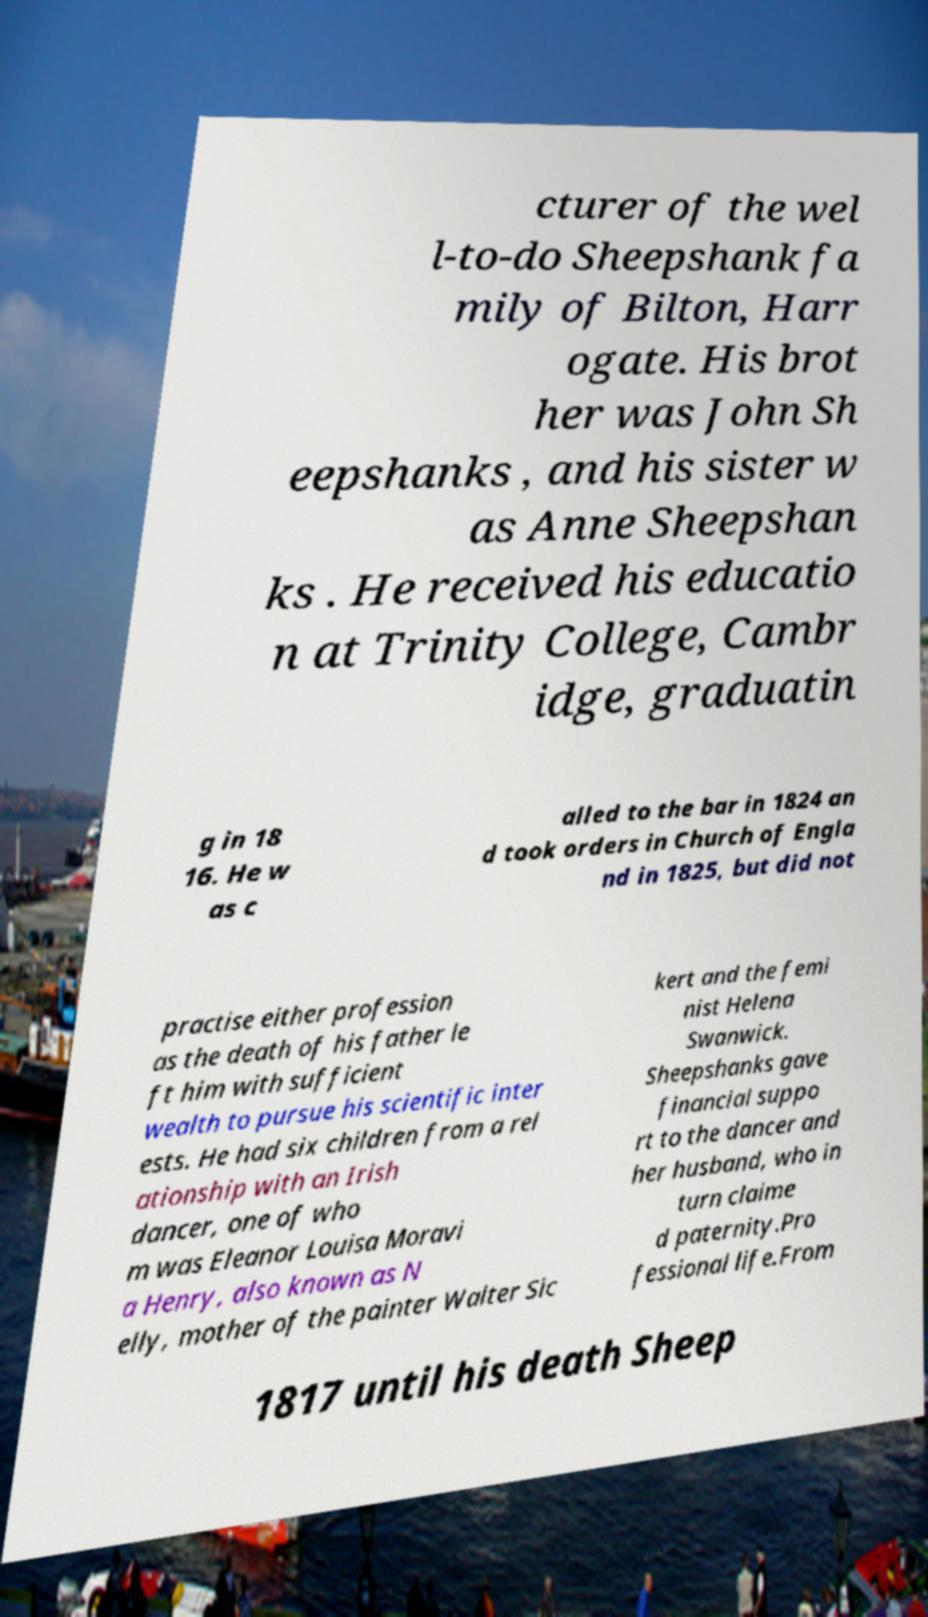There's text embedded in this image that I need extracted. Can you transcribe it verbatim? cturer of the wel l-to-do Sheepshank fa mily of Bilton, Harr ogate. His brot her was John Sh eepshanks , and his sister w as Anne Sheepshan ks . He received his educatio n at Trinity College, Cambr idge, graduatin g in 18 16. He w as c alled to the bar in 1824 an d took orders in Church of Engla nd in 1825, but did not practise either profession as the death of his father le ft him with sufficient wealth to pursue his scientific inter ests. He had six children from a rel ationship with an Irish dancer, one of who m was Eleanor Louisa Moravi a Henry, also known as N elly, mother of the painter Walter Sic kert and the femi nist Helena Swanwick. Sheepshanks gave financial suppo rt to the dancer and her husband, who in turn claime d paternity.Pro fessional life.From 1817 until his death Sheep 